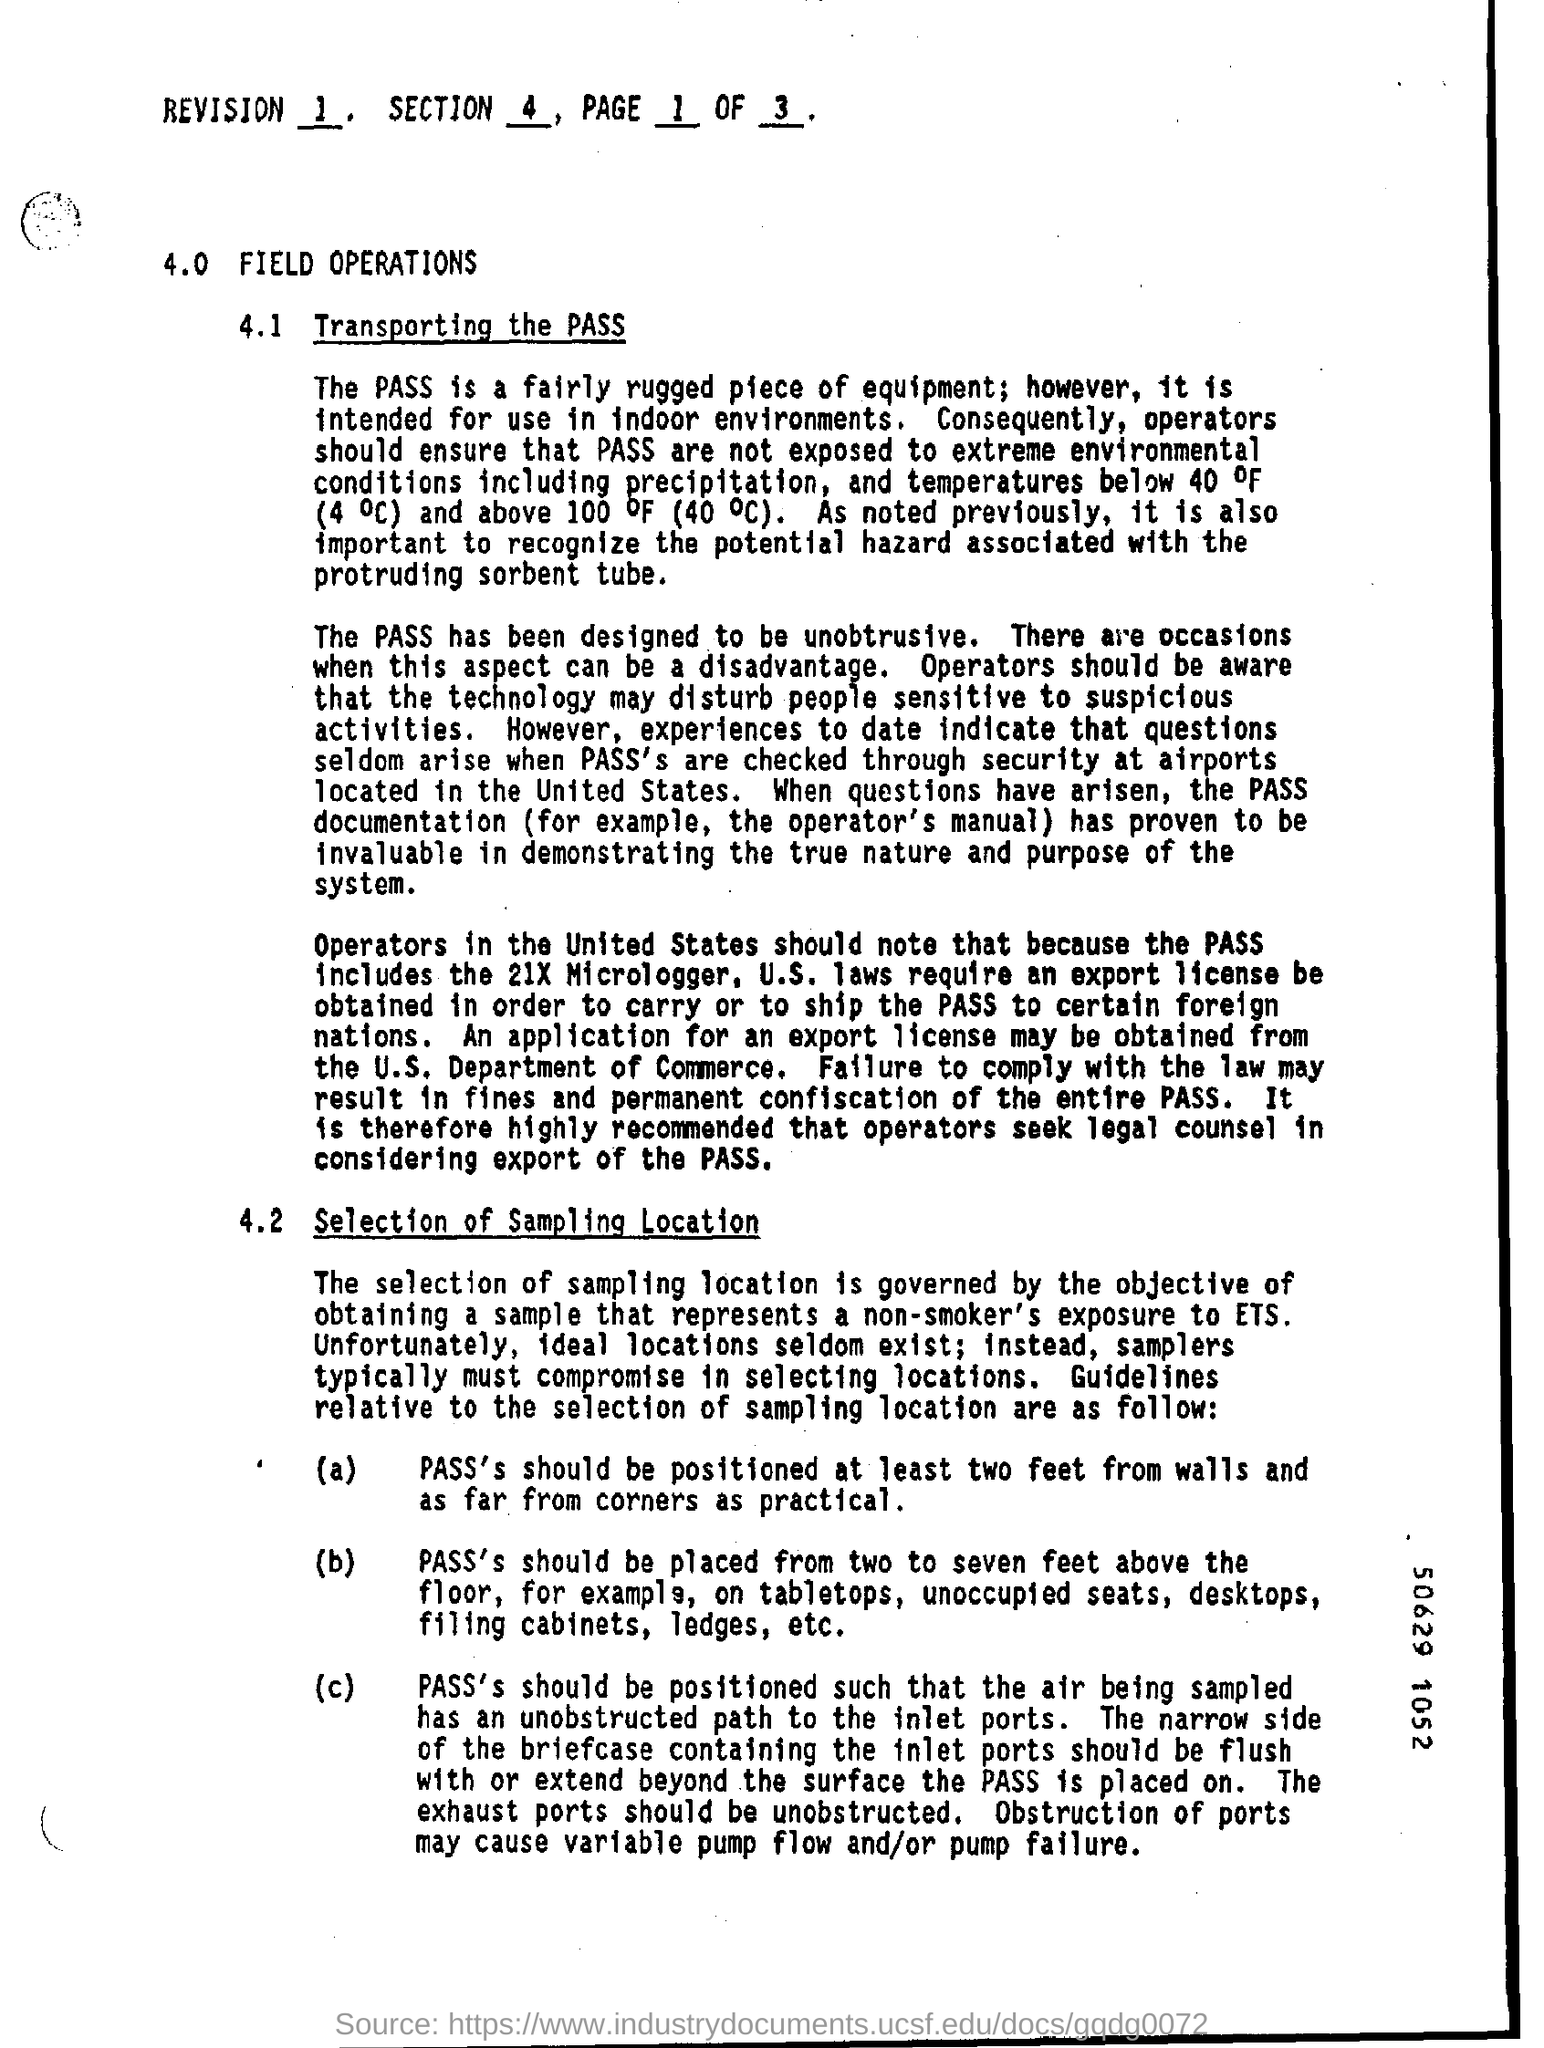List a handful of essential elements in this visual. At 4.0, the side heading is 'FIELD OPERATIONS'. The selection of the sampling location is crucial in determining the validity of the conclusions drawn from the sample. The SECTION number at the top of the page is 4. The "REVISION" number at the top of the page is 1. The subheading 4.1 is entitled 'Transporting the PASS Device' and concerns the process of moving the PASS device between different locations and environments. 